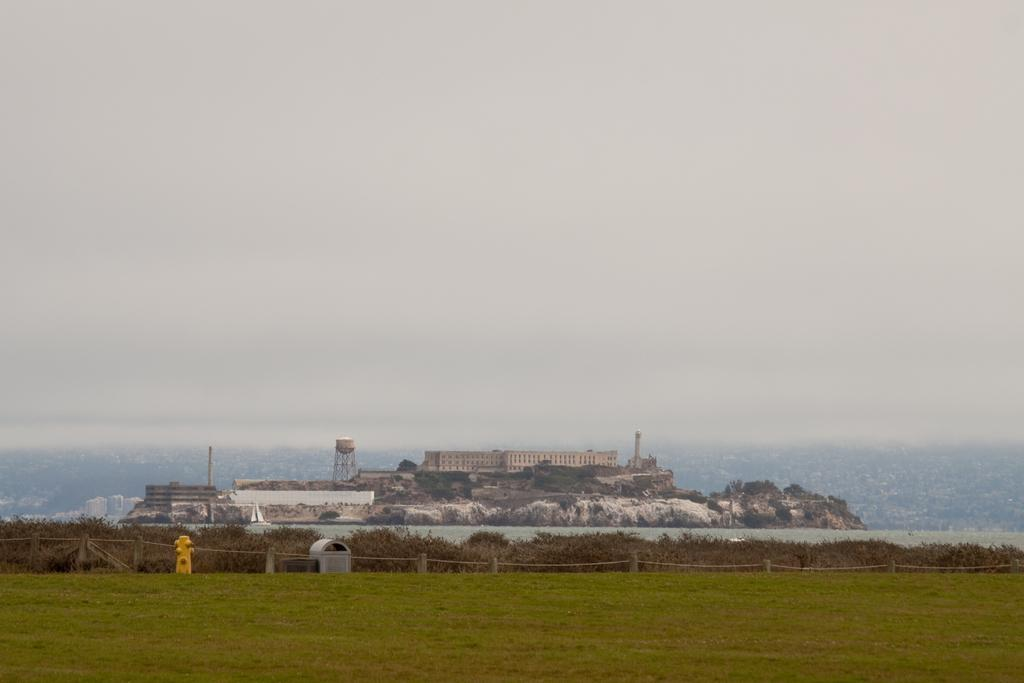What type of vegetation is at the bottom of the image? There is grass at the bottom of the image. What is located in the center of the image? There is a fence in the center of the image. What can be seen in the background of the image? There are buildings and bushes in the background of the image. What part of the natural environment is visible in the image? The sky is visible in the background of the image. What type of waste is present in the image? There is no waste present in the image. Does the existence of the fence in the image imply a division between two areas? The presence of the fence in the image does not necessarily imply a division between two areas, as it could be serving a decorative or boundary purpose. 